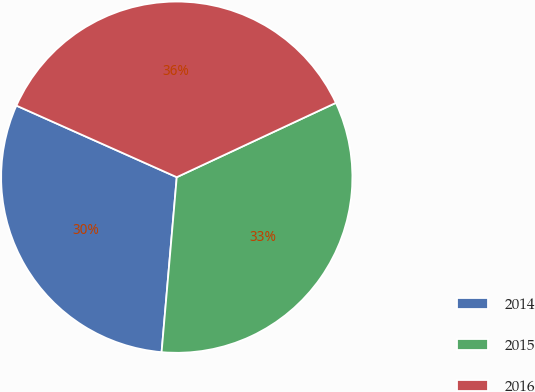<chart> <loc_0><loc_0><loc_500><loc_500><pie_chart><fcel>2014<fcel>2015<fcel>2016<nl><fcel>30.3%<fcel>33.33%<fcel>36.36%<nl></chart> 